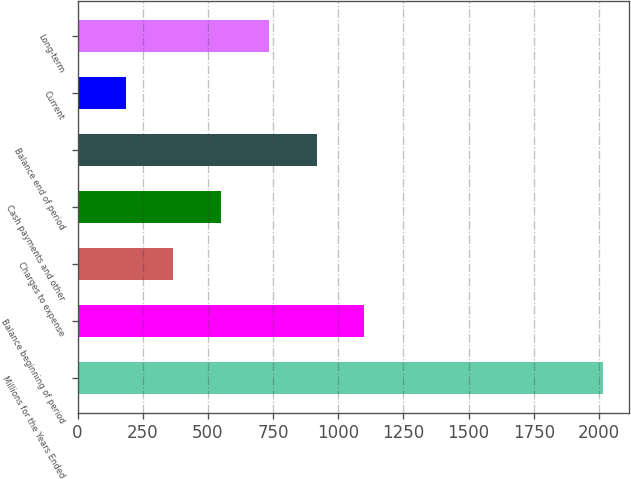Convert chart. <chart><loc_0><loc_0><loc_500><loc_500><bar_chart><fcel>Millions for the Years Ended<fcel>Balance beginning of period<fcel>Charges to expense<fcel>Cash payments and other<fcel>Balance end of period<fcel>Current<fcel>Long-term<nl><fcel>2016<fcel>1100.5<fcel>368.1<fcel>551.2<fcel>917.4<fcel>185<fcel>734.3<nl></chart> 